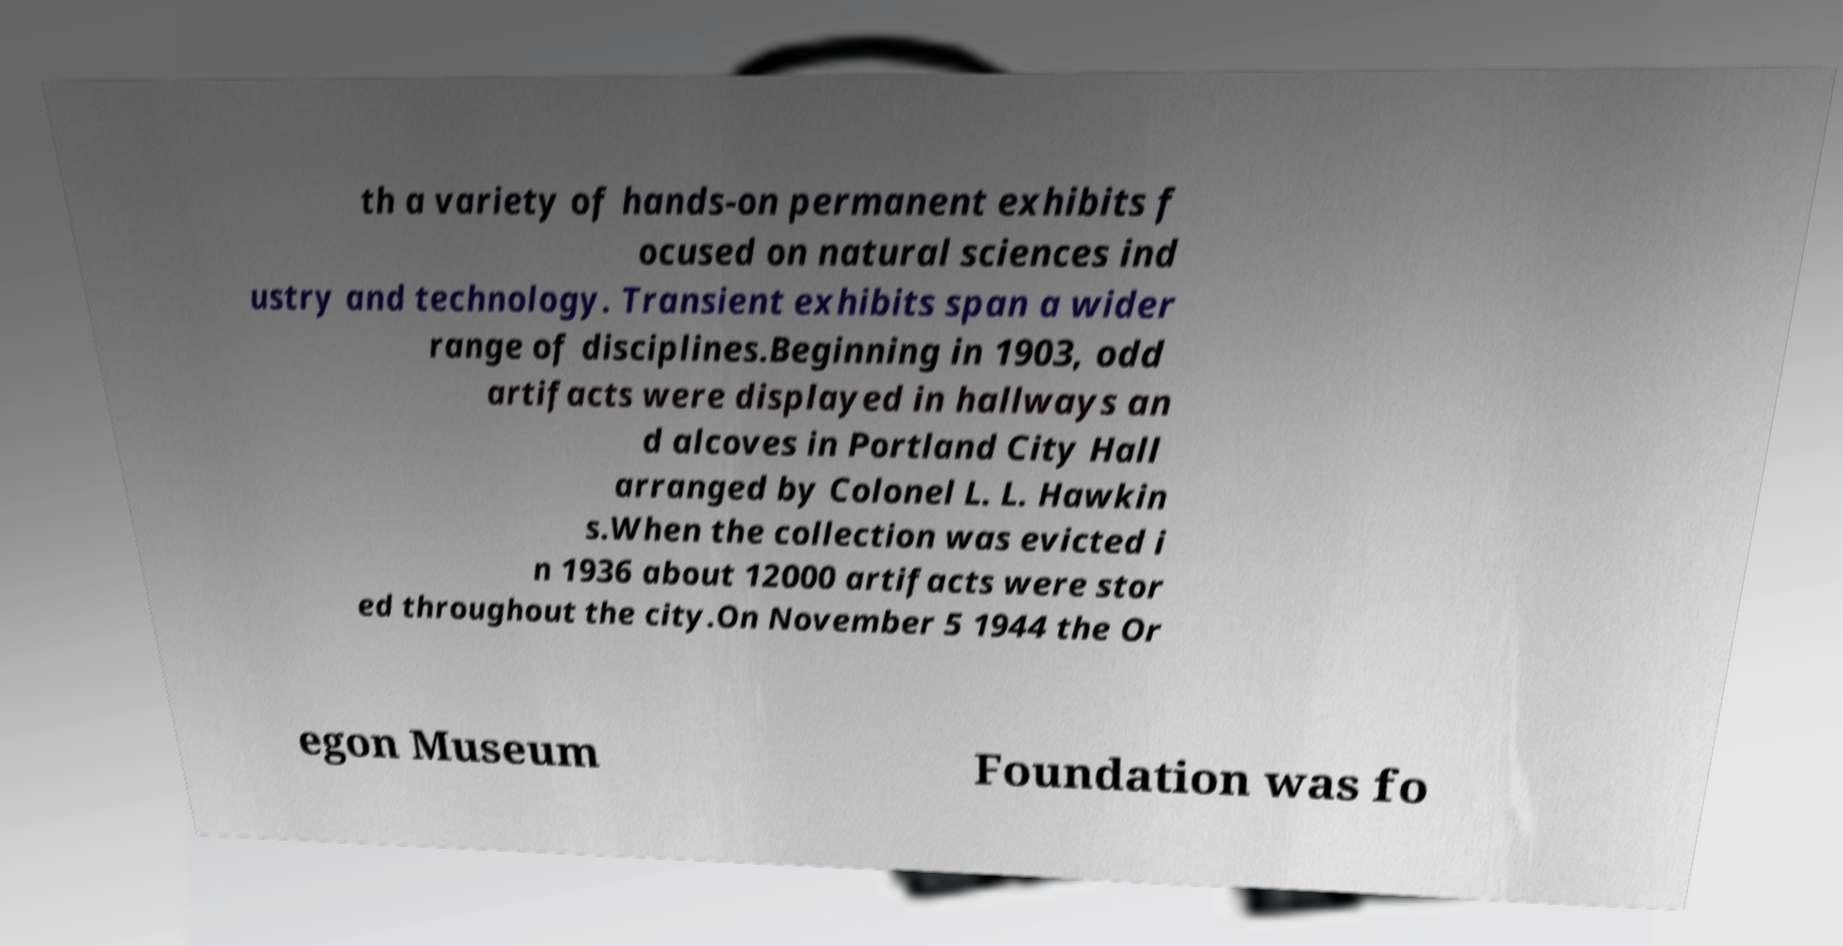For documentation purposes, I need the text within this image transcribed. Could you provide that? th a variety of hands-on permanent exhibits f ocused on natural sciences ind ustry and technology. Transient exhibits span a wider range of disciplines.Beginning in 1903, odd artifacts were displayed in hallways an d alcoves in Portland City Hall arranged by Colonel L. L. Hawkin s.When the collection was evicted i n 1936 about 12000 artifacts were stor ed throughout the city.On November 5 1944 the Or egon Museum Foundation was fo 